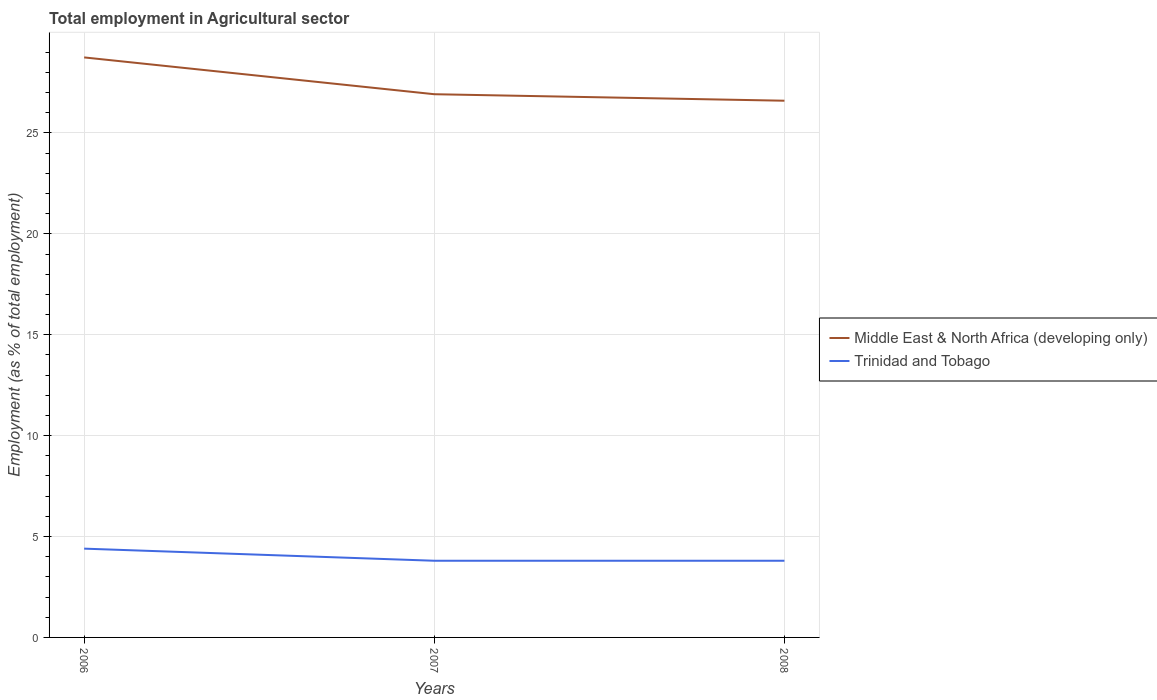Does the line corresponding to Trinidad and Tobago intersect with the line corresponding to Middle East & North Africa (developing only)?
Keep it short and to the point. No. Is the number of lines equal to the number of legend labels?
Ensure brevity in your answer.  Yes. Across all years, what is the maximum employment in agricultural sector in Trinidad and Tobago?
Offer a very short reply. 3.8. In which year was the employment in agricultural sector in Trinidad and Tobago maximum?
Your response must be concise. 2007. What is the total employment in agricultural sector in Middle East & North Africa (developing only) in the graph?
Offer a very short reply. 2.15. What is the difference between the highest and the second highest employment in agricultural sector in Trinidad and Tobago?
Ensure brevity in your answer.  0.6. Is the employment in agricultural sector in Middle East & North Africa (developing only) strictly greater than the employment in agricultural sector in Trinidad and Tobago over the years?
Your answer should be compact. No. How many lines are there?
Ensure brevity in your answer.  2. How many years are there in the graph?
Give a very brief answer. 3. What is the difference between two consecutive major ticks on the Y-axis?
Make the answer very short. 5. How many legend labels are there?
Your response must be concise. 2. How are the legend labels stacked?
Offer a very short reply. Vertical. What is the title of the graph?
Provide a short and direct response. Total employment in Agricultural sector. Does "Vietnam" appear as one of the legend labels in the graph?
Your answer should be compact. No. What is the label or title of the Y-axis?
Give a very brief answer. Employment (as % of total employment). What is the Employment (as % of total employment) in Middle East & North Africa (developing only) in 2006?
Provide a succinct answer. 28.74. What is the Employment (as % of total employment) in Trinidad and Tobago in 2006?
Offer a terse response. 4.4. What is the Employment (as % of total employment) in Middle East & North Africa (developing only) in 2007?
Provide a short and direct response. 26.92. What is the Employment (as % of total employment) of Trinidad and Tobago in 2007?
Your response must be concise. 3.8. What is the Employment (as % of total employment) in Middle East & North Africa (developing only) in 2008?
Your answer should be very brief. 26.6. What is the Employment (as % of total employment) in Trinidad and Tobago in 2008?
Make the answer very short. 3.8. Across all years, what is the maximum Employment (as % of total employment) of Middle East & North Africa (developing only)?
Your answer should be very brief. 28.74. Across all years, what is the maximum Employment (as % of total employment) of Trinidad and Tobago?
Provide a succinct answer. 4.4. Across all years, what is the minimum Employment (as % of total employment) of Middle East & North Africa (developing only)?
Give a very brief answer. 26.6. Across all years, what is the minimum Employment (as % of total employment) of Trinidad and Tobago?
Your answer should be compact. 3.8. What is the total Employment (as % of total employment) of Middle East & North Africa (developing only) in the graph?
Provide a succinct answer. 82.26. What is the total Employment (as % of total employment) in Trinidad and Tobago in the graph?
Ensure brevity in your answer.  12. What is the difference between the Employment (as % of total employment) of Middle East & North Africa (developing only) in 2006 and that in 2007?
Keep it short and to the point. 1.82. What is the difference between the Employment (as % of total employment) in Trinidad and Tobago in 2006 and that in 2007?
Make the answer very short. 0.6. What is the difference between the Employment (as % of total employment) of Middle East & North Africa (developing only) in 2006 and that in 2008?
Offer a very short reply. 2.15. What is the difference between the Employment (as % of total employment) of Trinidad and Tobago in 2006 and that in 2008?
Give a very brief answer. 0.6. What is the difference between the Employment (as % of total employment) in Middle East & North Africa (developing only) in 2007 and that in 2008?
Your answer should be very brief. 0.32. What is the difference between the Employment (as % of total employment) of Trinidad and Tobago in 2007 and that in 2008?
Your answer should be compact. 0. What is the difference between the Employment (as % of total employment) of Middle East & North Africa (developing only) in 2006 and the Employment (as % of total employment) of Trinidad and Tobago in 2007?
Offer a terse response. 24.94. What is the difference between the Employment (as % of total employment) of Middle East & North Africa (developing only) in 2006 and the Employment (as % of total employment) of Trinidad and Tobago in 2008?
Make the answer very short. 24.94. What is the difference between the Employment (as % of total employment) in Middle East & North Africa (developing only) in 2007 and the Employment (as % of total employment) in Trinidad and Tobago in 2008?
Give a very brief answer. 23.12. What is the average Employment (as % of total employment) in Middle East & North Africa (developing only) per year?
Offer a terse response. 27.42. What is the average Employment (as % of total employment) of Trinidad and Tobago per year?
Ensure brevity in your answer.  4. In the year 2006, what is the difference between the Employment (as % of total employment) of Middle East & North Africa (developing only) and Employment (as % of total employment) of Trinidad and Tobago?
Provide a short and direct response. 24.34. In the year 2007, what is the difference between the Employment (as % of total employment) in Middle East & North Africa (developing only) and Employment (as % of total employment) in Trinidad and Tobago?
Offer a very short reply. 23.12. In the year 2008, what is the difference between the Employment (as % of total employment) of Middle East & North Africa (developing only) and Employment (as % of total employment) of Trinidad and Tobago?
Offer a terse response. 22.8. What is the ratio of the Employment (as % of total employment) of Middle East & North Africa (developing only) in 2006 to that in 2007?
Offer a terse response. 1.07. What is the ratio of the Employment (as % of total employment) in Trinidad and Tobago in 2006 to that in 2007?
Make the answer very short. 1.16. What is the ratio of the Employment (as % of total employment) in Middle East & North Africa (developing only) in 2006 to that in 2008?
Offer a very short reply. 1.08. What is the ratio of the Employment (as % of total employment) of Trinidad and Tobago in 2006 to that in 2008?
Offer a very short reply. 1.16. What is the ratio of the Employment (as % of total employment) in Middle East & North Africa (developing only) in 2007 to that in 2008?
Provide a succinct answer. 1.01. What is the ratio of the Employment (as % of total employment) of Trinidad and Tobago in 2007 to that in 2008?
Keep it short and to the point. 1. What is the difference between the highest and the second highest Employment (as % of total employment) in Middle East & North Africa (developing only)?
Provide a short and direct response. 1.82. What is the difference between the highest and the second highest Employment (as % of total employment) in Trinidad and Tobago?
Ensure brevity in your answer.  0.6. What is the difference between the highest and the lowest Employment (as % of total employment) of Middle East & North Africa (developing only)?
Provide a short and direct response. 2.15. What is the difference between the highest and the lowest Employment (as % of total employment) in Trinidad and Tobago?
Offer a very short reply. 0.6. 